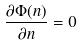<formula> <loc_0><loc_0><loc_500><loc_500>\frac { \partial \Phi ( n ) } { \partial n } = 0</formula> 